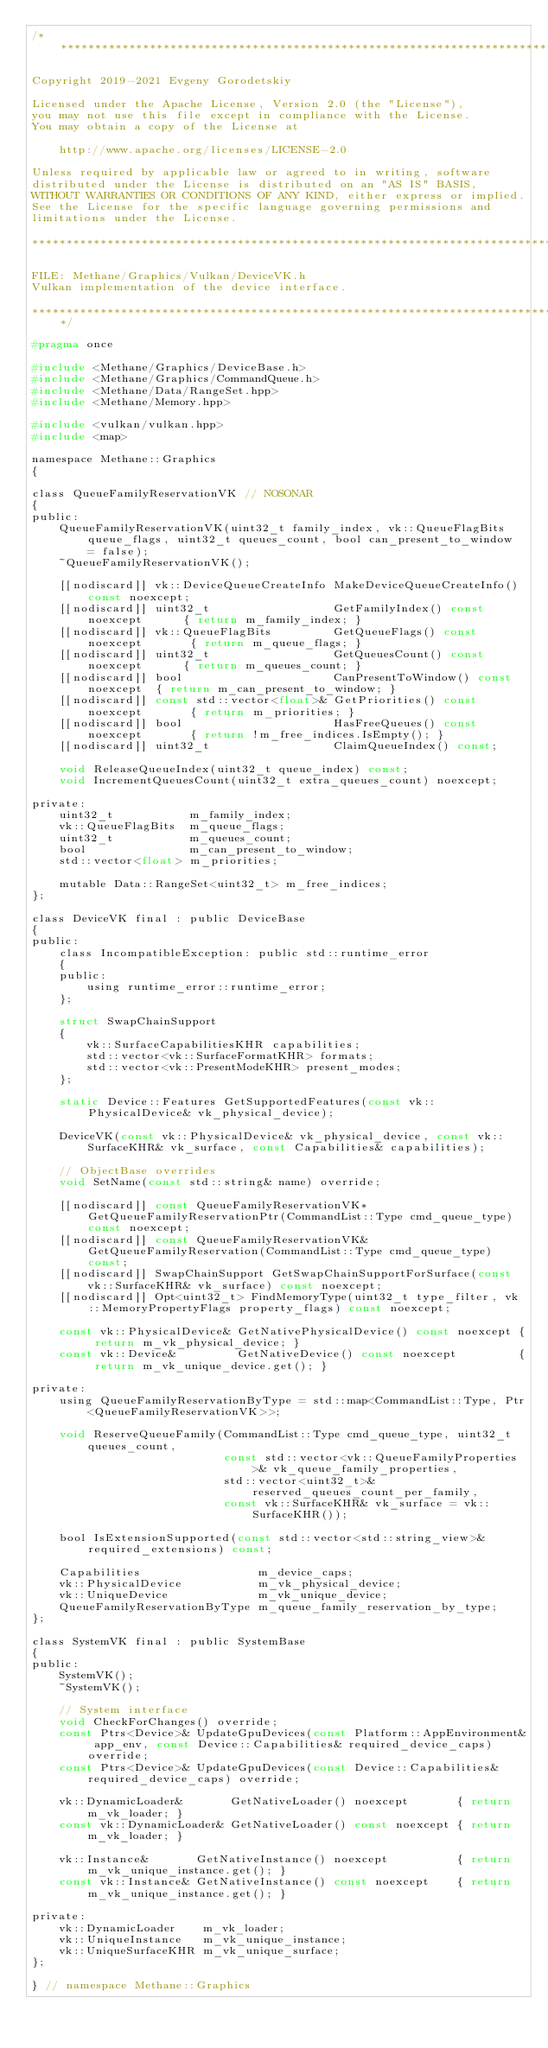<code> <loc_0><loc_0><loc_500><loc_500><_C_>/******************************************************************************

Copyright 2019-2021 Evgeny Gorodetskiy

Licensed under the Apache License, Version 2.0 (the "License"),
you may not use this file except in compliance with the License.
You may obtain a copy of the License at

    http://www.apache.org/licenses/LICENSE-2.0

Unless required by applicable law or agreed to in writing, software
distributed under the License is distributed on an "AS IS" BASIS,
WITHOUT WARRANTIES OR CONDITIONS OF ANY KIND, either express or implied.
See the License for the specific language governing permissions and
limitations under the License.

*******************************************************************************

FILE: Methane/Graphics/Vulkan/DeviceVK.h
Vulkan implementation of the device interface.

******************************************************************************/

#pragma once

#include <Methane/Graphics/DeviceBase.h>
#include <Methane/Graphics/CommandQueue.h>
#include <Methane/Data/RangeSet.hpp>
#include <Methane/Memory.hpp>

#include <vulkan/vulkan.hpp>
#include <map>

namespace Methane::Graphics
{

class QueueFamilyReservationVK // NOSONAR
{
public:
    QueueFamilyReservationVK(uint32_t family_index, vk::QueueFlagBits queue_flags, uint32_t queues_count, bool can_present_to_window = false);
    ~QueueFamilyReservationVK();

    [[nodiscard]] vk::DeviceQueueCreateInfo MakeDeviceQueueCreateInfo() const noexcept;
    [[nodiscard]] uint32_t                  GetFamilyIndex() const noexcept      { return m_family_index; }
    [[nodiscard]] vk::QueueFlagBits         GetQueueFlags() const noexcept       { return m_queue_flags; }
    [[nodiscard]] uint32_t                  GetQueuesCount() const noexcept      { return m_queues_count; }
    [[nodiscard]] bool                      CanPresentToWindow() const noexcept  { return m_can_present_to_window; }
    [[nodiscard]] const std::vector<float>& GetPriorities() const noexcept       { return m_priorities; }
    [[nodiscard]] bool                      HasFreeQueues() const noexcept       { return !m_free_indices.IsEmpty(); }
    [[nodiscard]] uint32_t                  ClaimQueueIndex() const;

    void ReleaseQueueIndex(uint32_t queue_index) const;
    void IncrementQueuesCount(uint32_t extra_queues_count) noexcept;

private:
    uint32_t           m_family_index;
    vk::QueueFlagBits  m_queue_flags;
    uint32_t           m_queues_count;
    bool               m_can_present_to_window;
    std::vector<float> m_priorities;

    mutable Data::RangeSet<uint32_t> m_free_indices;
};

class DeviceVK final : public DeviceBase
{
public:
    class IncompatibleException: public std::runtime_error
    {
    public:
        using runtime_error::runtime_error;
    };

    struct SwapChainSupport
    {
        vk::SurfaceCapabilitiesKHR capabilities;
        std::vector<vk::SurfaceFormatKHR> formats;
        std::vector<vk::PresentModeKHR> present_modes;
    };

    static Device::Features GetSupportedFeatures(const vk::PhysicalDevice& vk_physical_device);

    DeviceVK(const vk::PhysicalDevice& vk_physical_device, const vk::SurfaceKHR& vk_surface, const Capabilities& capabilities);

    // ObjectBase overrides
    void SetName(const std::string& name) override;

    [[nodiscard]] const QueueFamilyReservationVK* GetQueueFamilyReservationPtr(CommandList::Type cmd_queue_type) const noexcept;
    [[nodiscard]] const QueueFamilyReservationVK& GetQueueFamilyReservation(CommandList::Type cmd_queue_type) const;
    [[nodiscard]] SwapChainSupport GetSwapChainSupportForSurface(const vk::SurfaceKHR& vk_surface) const noexcept;
    [[nodiscard]] Opt<uint32_t> FindMemoryType(uint32_t type_filter, vk::MemoryPropertyFlags property_flags) const noexcept;

    const vk::PhysicalDevice& GetNativePhysicalDevice() const noexcept { return m_vk_physical_device; }
    const vk::Device&         GetNativeDevice() const noexcept         { return m_vk_unique_device.get(); }

private:
    using QueueFamilyReservationByType = std::map<CommandList::Type, Ptr<QueueFamilyReservationVK>>;

    void ReserveQueueFamily(CommandList::Type cmd_queue_type, uint32_t queues_count,
                            const std::vector<vk::QueueFamilyProperties>& vk_queue_family_properties,
                            std::vector<uint32_t>& reserved_queues_count_per_family,
                            const vk::SurfaceKHR& vk_surface = vk::SurfaceKHR());

    bool IsExtensionSupported(const std::vector<std::string_view>& required_extensions) const;

    Capabilities                 m_device_caps;
    vk::PhysicalDevice           m_vk_physical_device;
    vk::UniqueDevice             m_vk_unique_device;
    QueueFamilyReservationByType m_queue_family_reservation_by_type;
};

class SystemVK final : public SystemBase
{
public:
    SystemVK();
    ~SystemVK();

    // System interface
    void CheckForChanges() override;
    const Ptrs<Device>& UpdateGpuDevices(const Platform::AppEnvironment& app_env, const Device::Capabilities& required_device_caps) override;
    const Ptrs<Device>& UpdateGpuDevices(const Device::Capabilities& required_device_caps) override;

    vk::DynamicLoader&       GetNativeLoader() noexcept       { return m_vk_loader; }
    const vk::DynamicLoader& GetNativeLoader() const noexcept { return m_vk_loader; }

    vk::Instance&       GetNativeInstance() noexcept          { return m_vk_unique_instance.get(); }
    const vk::Instance& GetNativeInstance() const noexcept    { return m_vk_unique_instance.get(); }

private:    
    vk::DynamicLoader    m_vk_loader;
    vk::UniqueInstance   m_vk_unique_instance;
    vk::UniqueSurfaceKHR m_vk_unique_surface;
};

} // namespace Methane::Graphics
</code> 